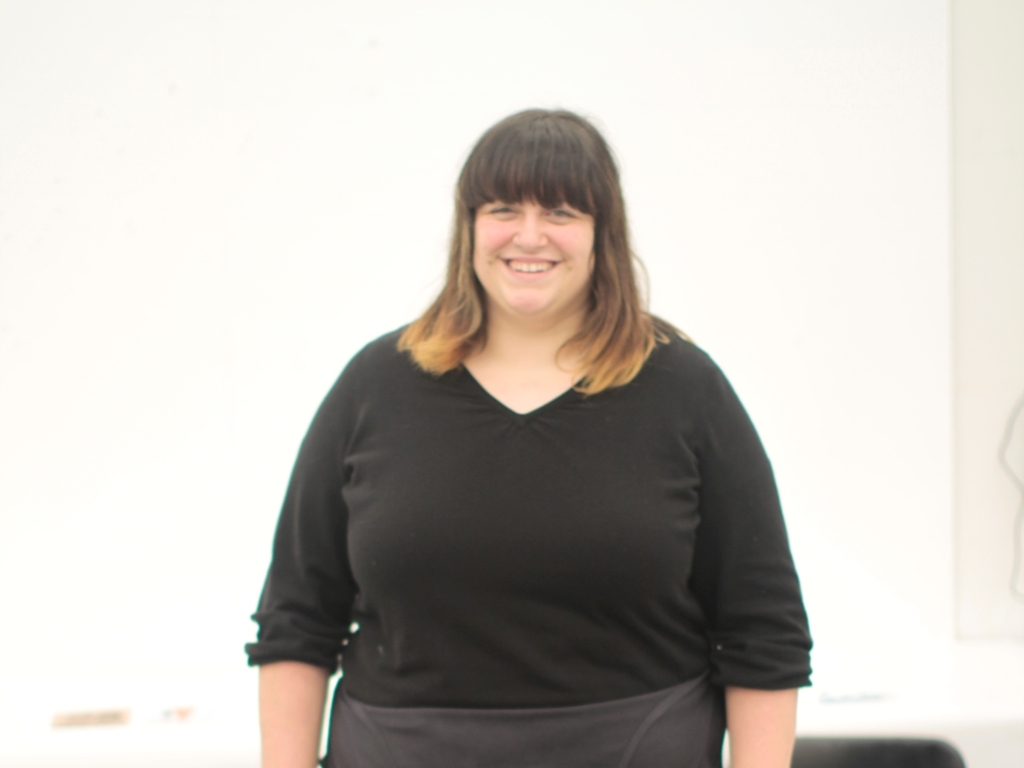Can you comment on the lighting and quality of the photograph? The photograph is well-lit with soft, diffuse lighting that minimizes harsh shadows and creates an inviting, warm atmosphere. The quality of the image is high, with good resolution and focus on the subject, which brings clarity and attention to the details in her attire and expression. 